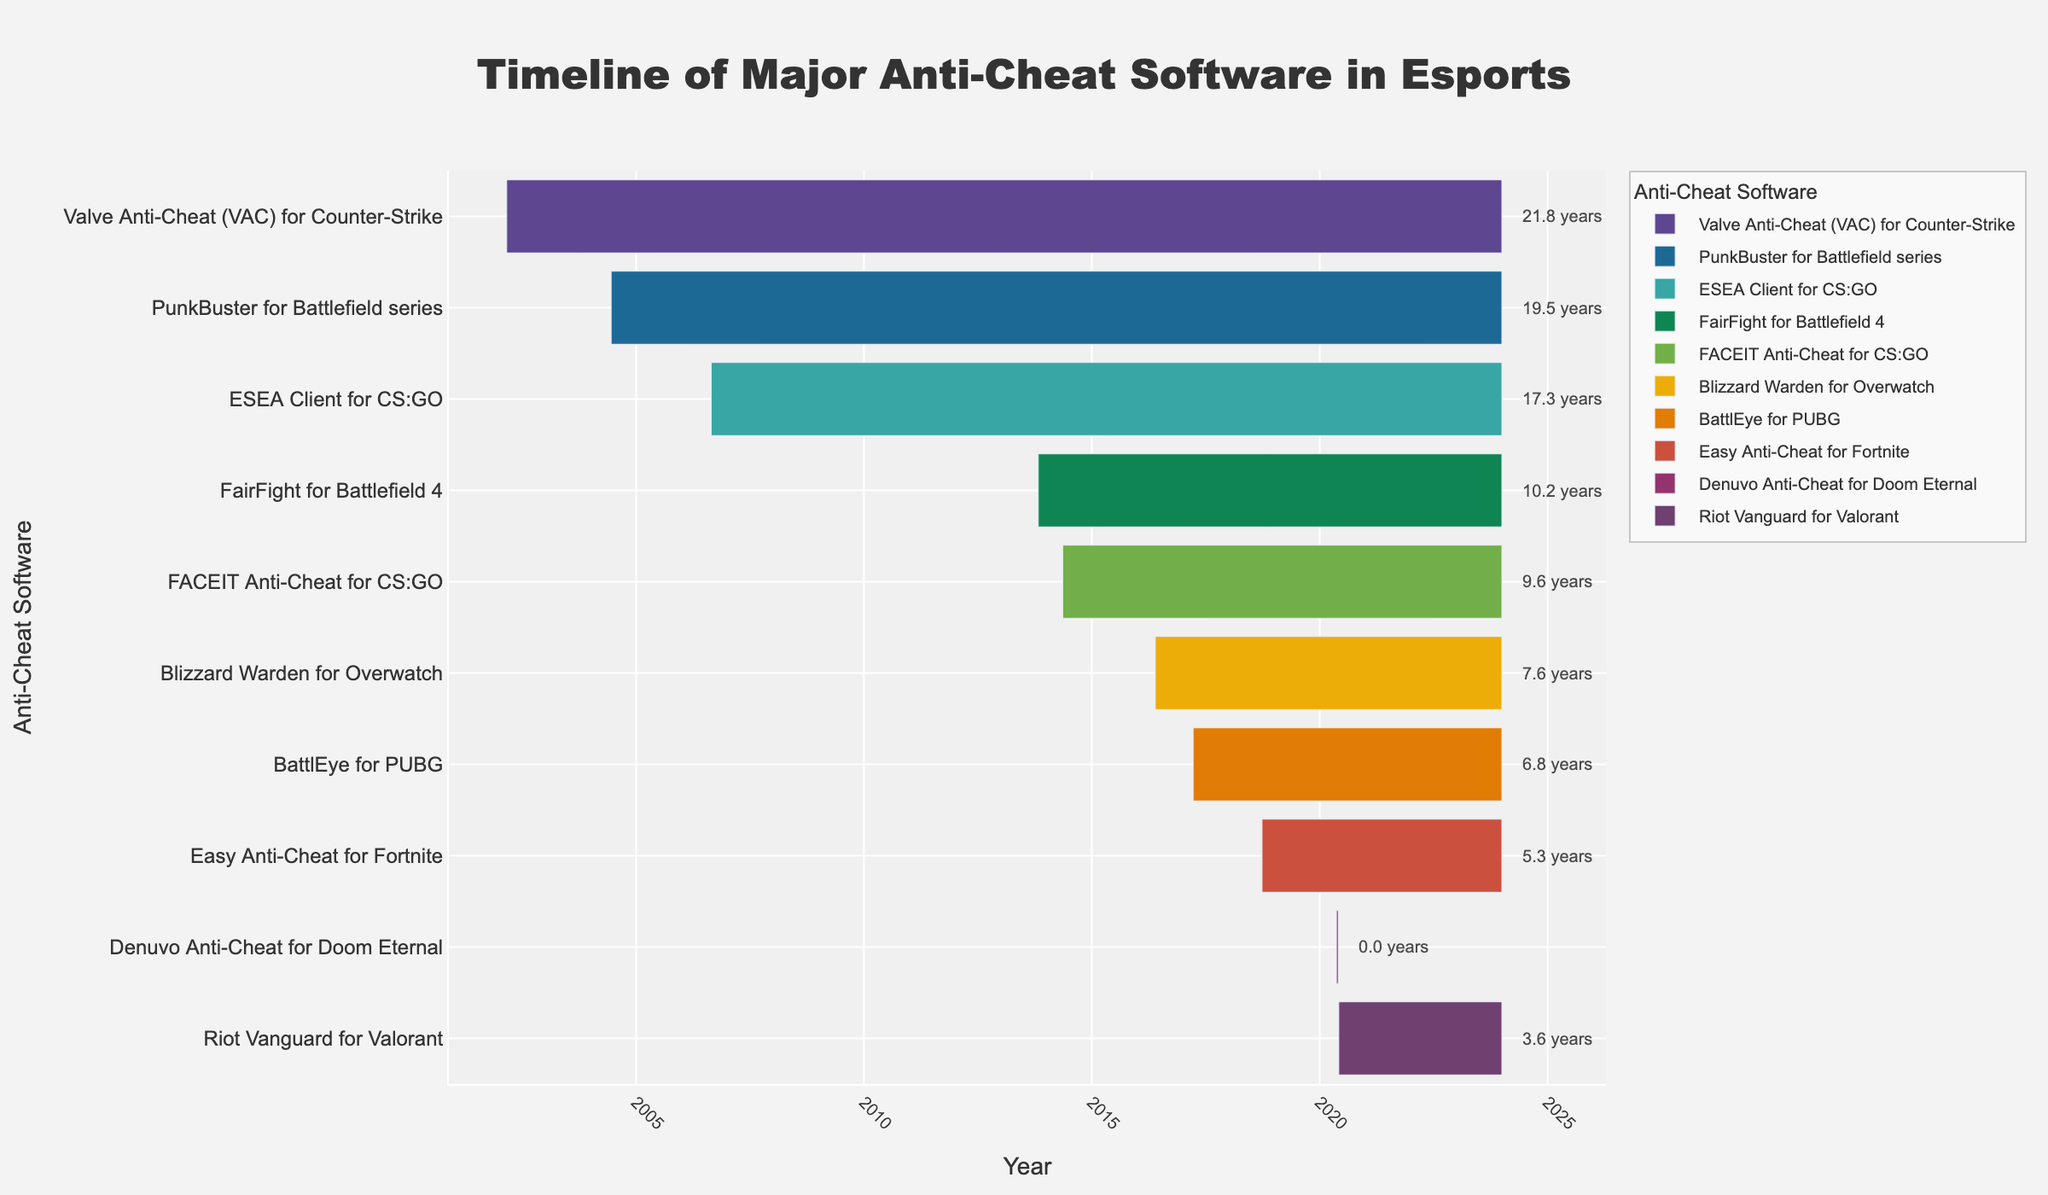Who is the longest-running anti-cheat software in the timeline? To determine the longest-running anti-cheat software, look at the start and end dates and find the one with the earliest start date and still active. Valve Anti-Cheat (VAC) started in 2002 and continues to be used as of the end date in 2023.
Answer: Valve Anti-Cheat (VAC) Which anti-cheat software was implemented most recently and is still in use? Identify the anti-cheat software with the latest start date that continues to be active. Denuvo Anti-Cheat for Doom Eternal was implemented in 2020 but only lasted for a short period, while Riot Vanguard for Valorant started in June 2020 and is still in use.
Answer: Riot Vanguard for Valorant How many years was Denuvo Anti-Cheat used for Doom Eternal in place? Look for the duration annotation next to Denuvo Anti-Cheat for Doom Eternal. The annotation next to Denuvo Anti-Cheat for Doom Eternal indicates a duration of 0.0 years.
Answer: 0.0 years What is the average duration (in years) of the anti-cheat software programs listed? Calculate the average of all the durations annotated next to each anti-cheat software. First sum up all the durations: 21.8 + 19.6 + 10.2 + 3.6 + 6.8 + 5.3 + 9.6 + 7.6 + 0.0 + 17.4 = 102.3 years. There are ten anti-cheat programs, so the average duration is 102.3/10 = 10.2 years.
Answer: 10.2 years Which anti-cheat software started the same year? Identify any anti-cheat software with the same start date or year by comparing their start dates. None of the anti-cheat software in the data provided has the same start year.
Answer: None Which anti-cheat software ended in the shortest period? Compare the end and start dates of each anti-cheat software and identify the one with the shortest duration. Denuvo Anti-Cheat for Doom Eternal was implemented and ended in May 2020, lasting only 0.0 years.
Answer: Denuvo Anti-Cheat for Doom Eternal 